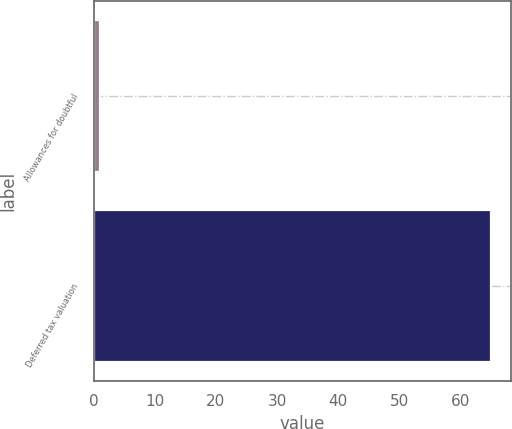Convert chart. <chart><loc_0><loc_0><loc_500><loc_500><bar_chart><fcel>Allowances for doubtful<fcel>Deferred tax valuation<nl><fcel>1<fcel>65<nl></chart> 